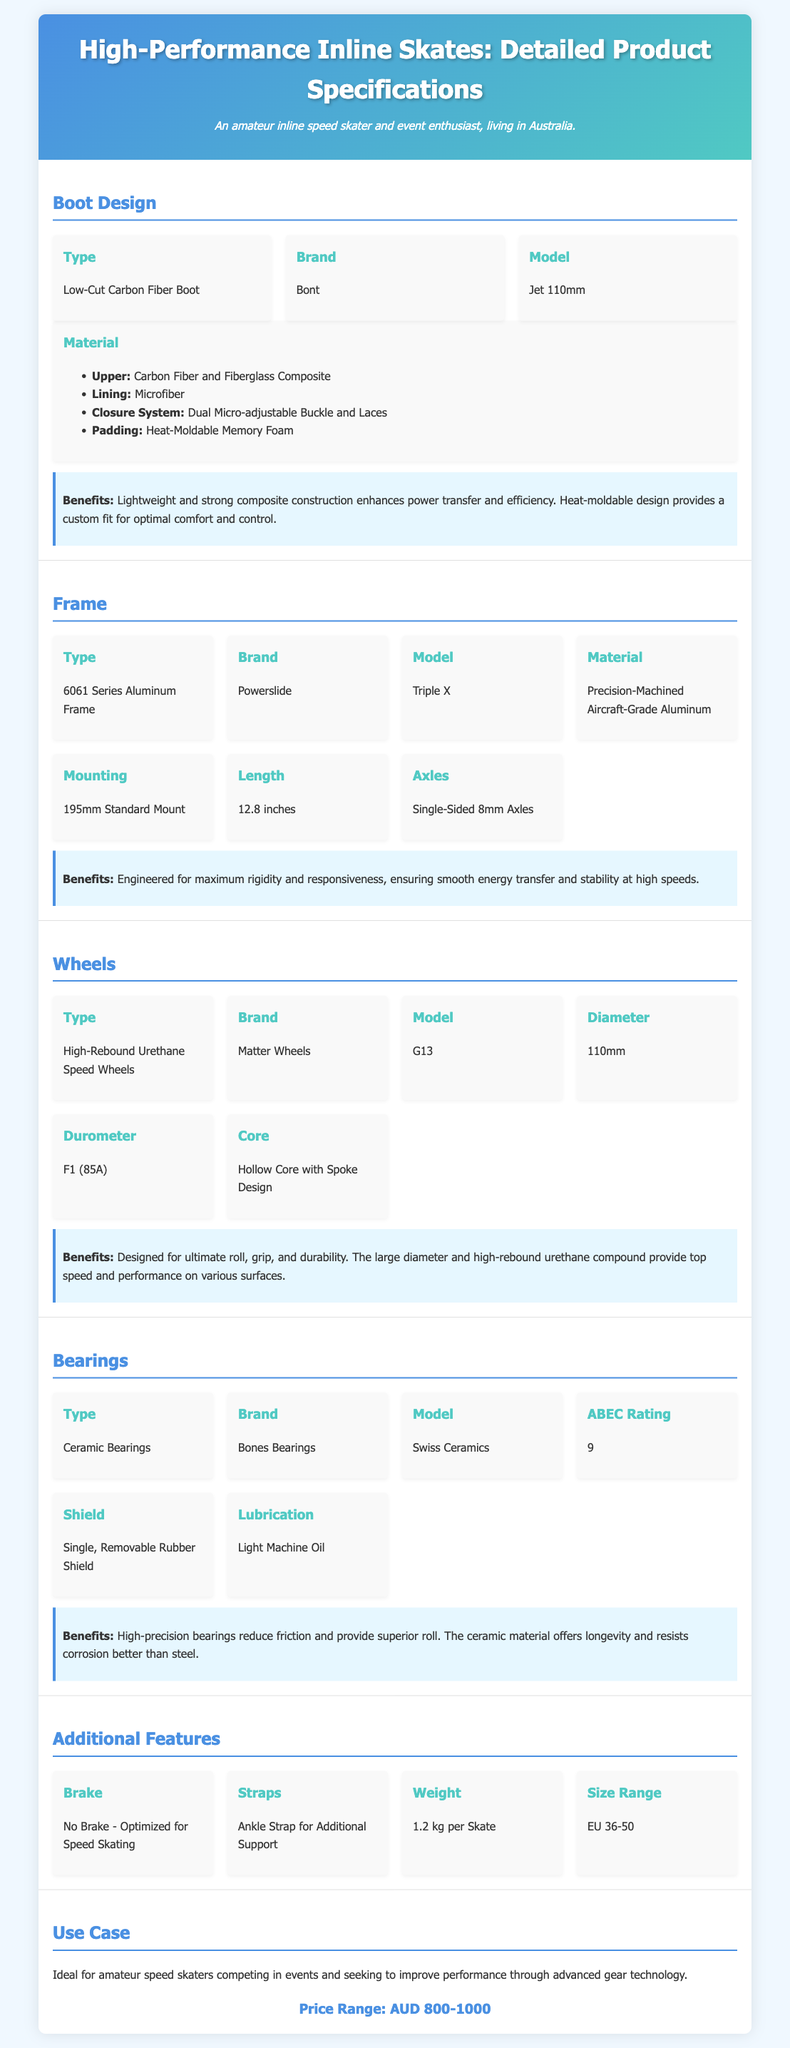what is the model of the boot? The document specifies that the boot model is "Jet 110mm."
Answer: Jet 110mm what material is used for the upper of the boot? According to the document, the upper is made of "Carbon Fiber and Fiberglass Composite."
Answer: Carbon Fiber and Fiberglass Composite which brand manufactures the wheels? The document states that the wheels are manufactured by "Matter Wheels."
Answer: Matter Wheels what is the durometer rating of the wheels? The durometer rating indicated in the document is "F1 (85A)."
Answer: F1 (85A) what is the weight of each skate? The document mentions that each skate weighs "1.2 kg."
Answer: 1.2 kg what type of bearings are used in the skates? The type of bearings specified in the document is "Ceramic Bearings."
Answer: Ceramic Bearings how is the closure system of the boot designed? The closure system is described as "Dual Micro-adjustable Buckle and Laces," indicating enhanced adjustability.
Answer: Dual Micro-adjustable Buckle and Laces what is the price range for these inline skates? The document lists the price range as "AUD 800-1000."
Answer: AUD 800-1000 what is the length of the frame? The document states that the length of the frame is "12.8 inches."
Answer: 12.8 inches 